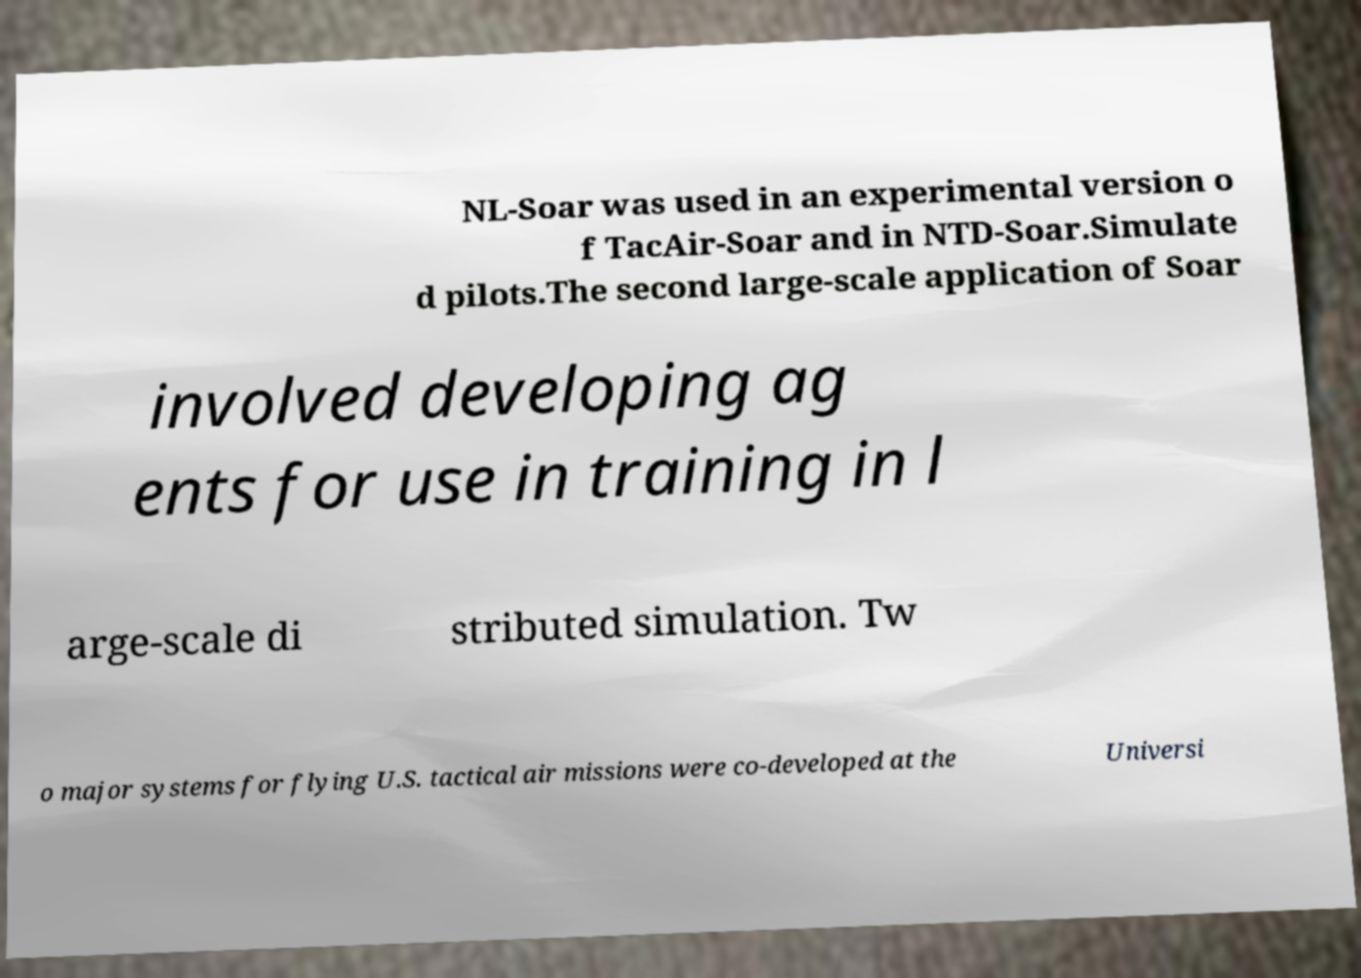Please read and relay the text visible in this image. What does it say? NL-Soar was used in an experimental version o f TacAir-Soar and in NTD-Soar.Simulate d pilots.The second large-scale application of Soar involved developing ag ents for use in training in l arge-scale di stributed simulation. Tw o major systems for flying U.S. tactical air missions were co-developed at the Universi 